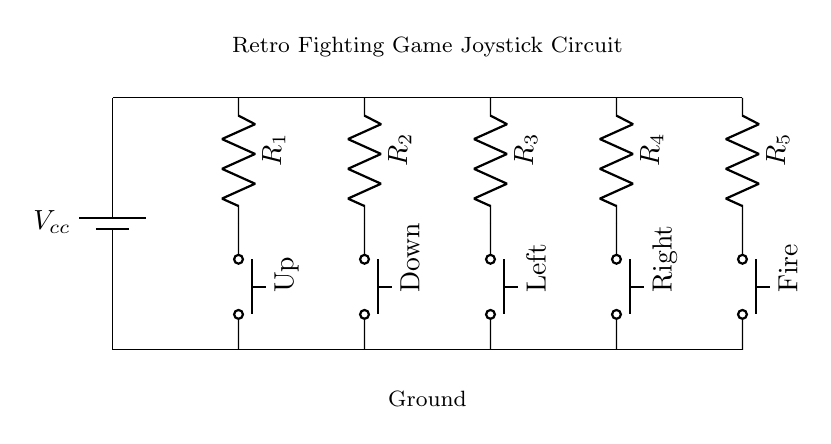What is the total number of push buttons in this circuit? The circuit diagram shows five push buttons labeled Up, Down, Left, Right, and Fire. These are the controls for the joystick. Count the individual push button symbols in the diagram.
Answer: Five What do the resistors in the circuit represent? In this circuit, the resistors are denoted as R1, R2, R3, R4, and R5. They typically limit the current that flows through the circuit when a button is pressed, providing a way to manage the signals sent to the system.
Answer: Resistors What voltage source is used in this circuit? In the diagram, a battery labeled Vcc is shown as the power source. This indicates that the circuit operates using a direct current (DC) supply from the battery, which is typical in arcade designs for reliable power.
Answer: Vcc How many directions can be controlled by this joystick circuit? The diagram illustrates four directional controls: Up, Down, Left, and Right, along with a Fire action. These controls are essential in fighting games for character movements and actions. Count the directional push buttons.
Answer: Four What happens when a push button is pressed? Pressing a push button completes a circuit path by allowing current to flow through the respective resistor and push button combination, sending a signal to the main controller of the game. This action corresponds to executing a specific player command in the game.
Answer: Signal sent Which component is used to measure resistance in this circuit? The components labeled R1, R2, R3, R4, and R5 represent resistors. Each resistor value can be measured to determine how much opposition is provided to the current in each pathway when the buttons are pressed.
Answer: Resistors 